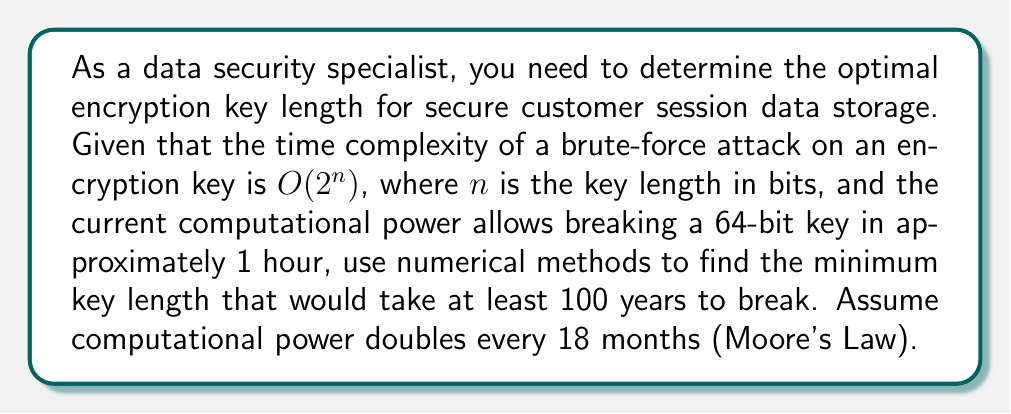Can you solve this math problem? 1. Let's define our variables:
   $n$: key length in bits
   $t$: time to break the key in years
   $d$: doubling of computational power (18 months = 1.5 years)

2. We know that for a 64-bit key, $t_{64} = \frac{1}{24 \times 365} \approx 1.14 \times 10^{-4}$ years

3. The time to break an $n$-bit key is proportional to $2^n$. So we can write:
   $t_n = t_{64} \times \frac{2^n}{2^{64}}$

4. Accounting for Moore's Law, after $y$ years, the time becomes:
   $t_n(y) = \frac{t_{64} \times 2^n}{2^{64} \times 2^{y/d}}$

5. We want to find $n$ such that $t_n(100) \geq 100$ years:
   $\frac{1.14 \times 10^{-4} \times 2^n}{2^{64} \times 2^{100/1.5}} \geq 100$

6. Solving for $n$:
   $2^n \geq 100 \times 2^{64} \times 2^{100/1.5} \times \frac{1}{1.14 \times 10^{-4}}$
   $n \geq \log_2(100 \times 2^{64} \times 2^{66.67} \times 8772.11)$
   $n \geq 64 + 66.67 + \log_2(100 \times 8772.11)$
   $n \geq 137.54$

7. Since $n$ must be an integer, we round up to the nearest whole number.
Answer: 138 bits 